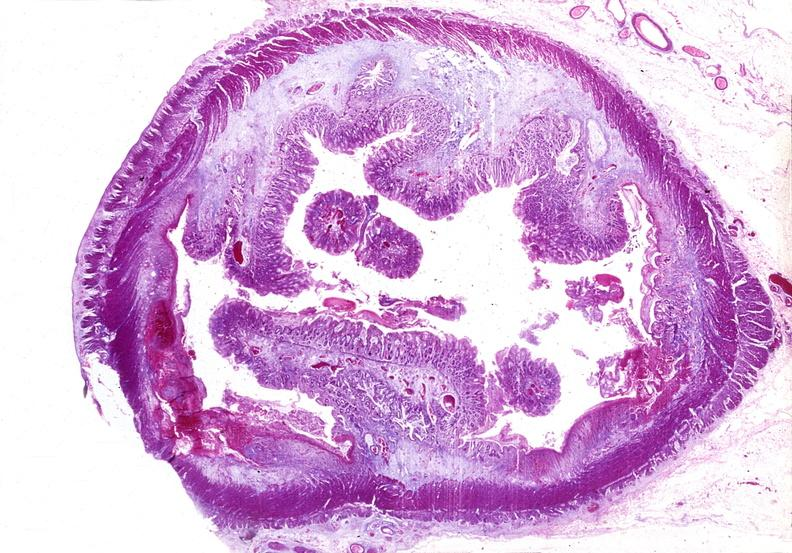s acid present?
Answer the question using a single word or phrase. No 